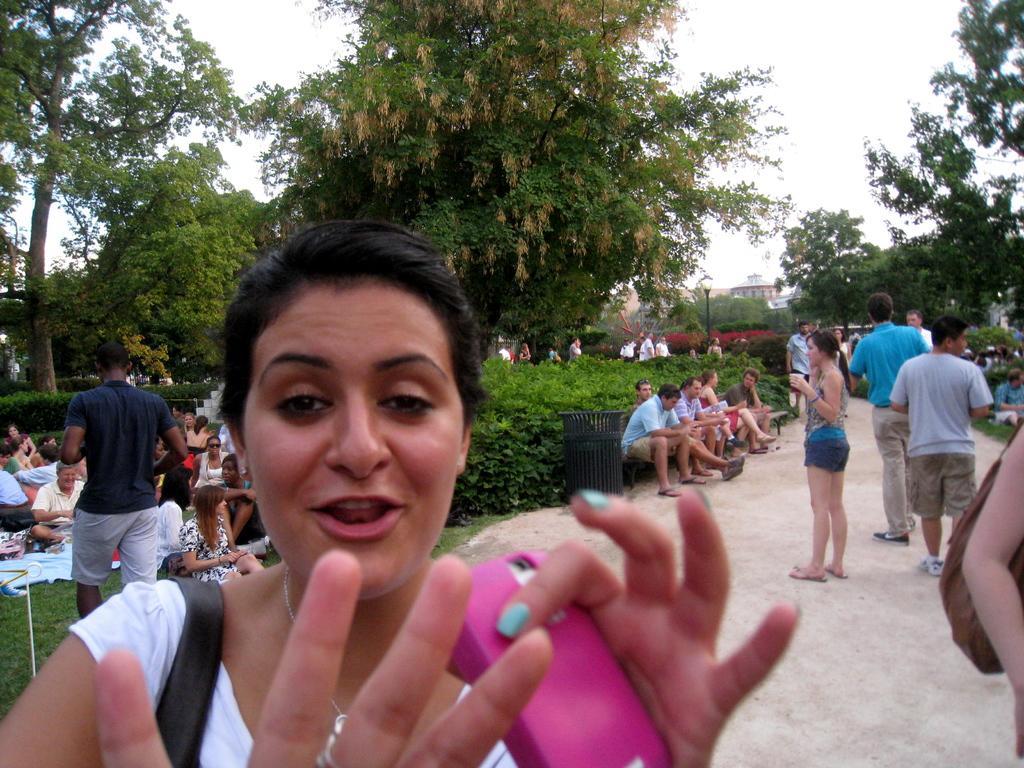In one or two sentences, can you explain what this image depicts? In this picture we can observe a woman wearing white color t-shirt and holding a pink color mobile in her hand. There are some people sitting on the bench and standing in this path. We can observe some trees and plants here. In the background there is a sky. 